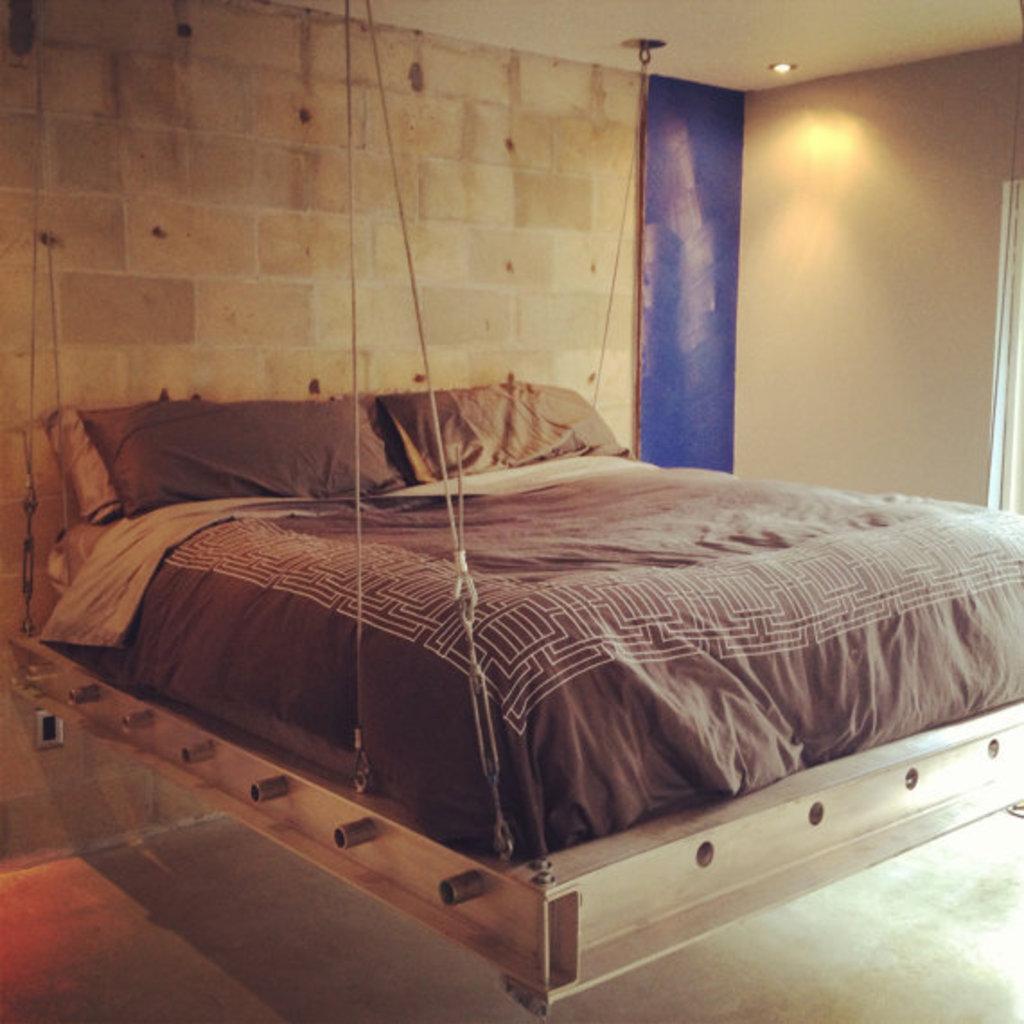How would you summarize this image in a sentence or two? In the picture I can see a bed, lifted by metal strings. I can see the mattress and pillows on the bed. I can see a light on the roof. 